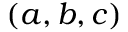Convert formula to latex. <formula><loc_0><loc_0><loc_500><loc_500>( a , b , c )</formula> 